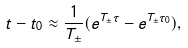<formula> <loc_0><loc_0><loc_500><loc_500>t - t _ { 0 } \approx \frac { 1 } { T _ { \pm } } ( e ^ { T _ { \pm } \tau } - e ^ { T _ { \pm } \tau _ { 0 } } ) ,</formula> 